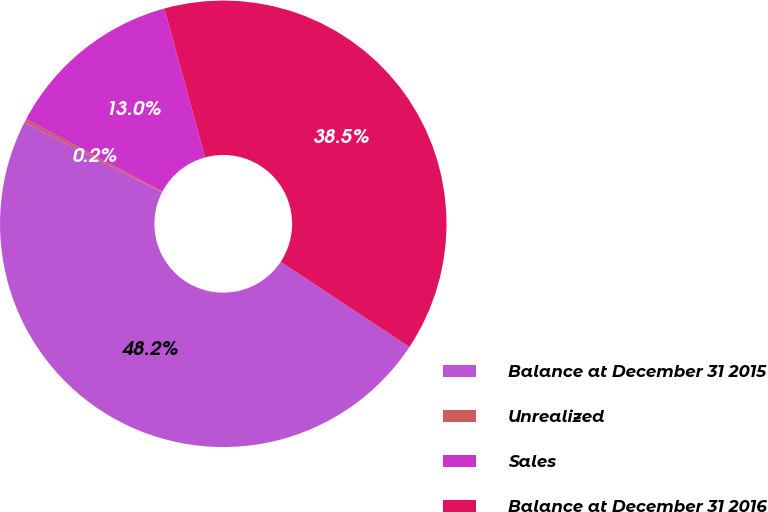<chart> <loc_0><loc_0><loc_500><loc_500><pie_chart><fcel>Balance at December 31 2015<fcel>Unrealized<fcel>Sales<fcel>Balance at December 31 2016<nl><fcel>48.22%<fcel>0.23%<fcel>13.0%<fcel>38.55%<nl></chart> 